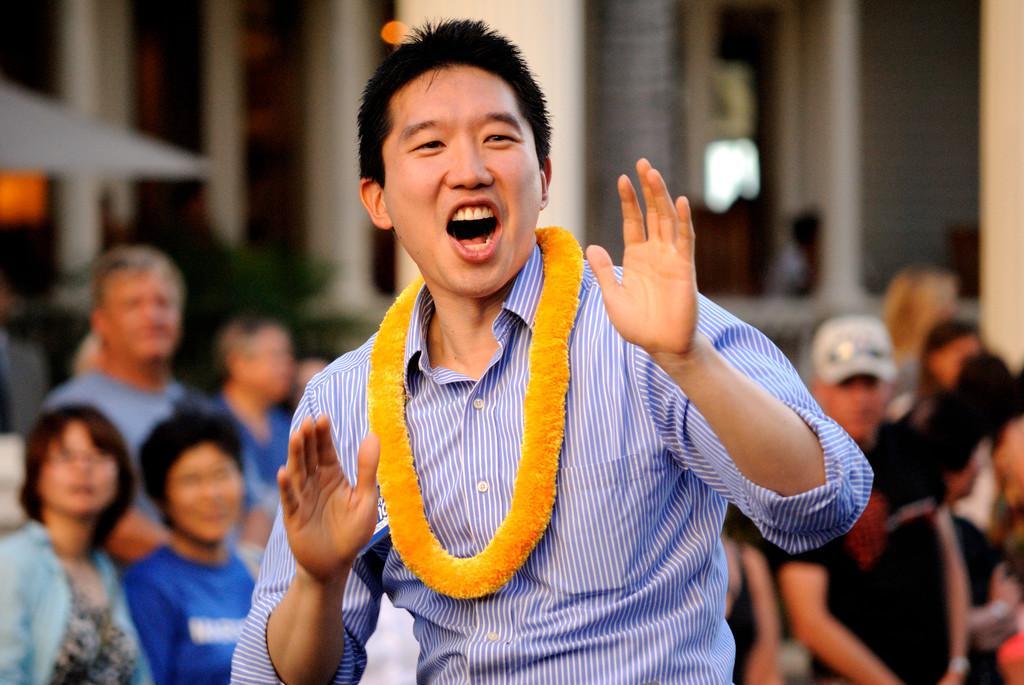How would you summarize this image in a sentence or two? In this picture I can observe a person. He is wearing purple color shirt and yellow color garland in his neck. In the background there are some people standing and it is partially blurred. 